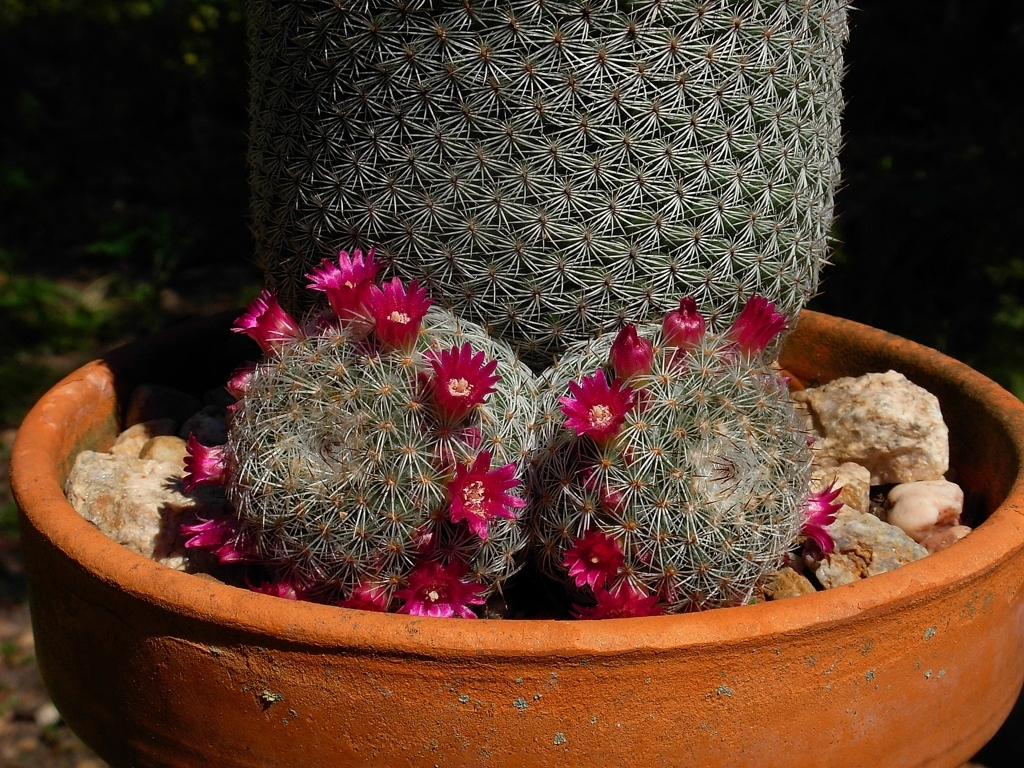Could you describe the types of thorns this cactus has? Certainly, the cactus has an array of closely packed, needle-like spines covering its surface. These spines vary in length and are an adaptation to protect the cactus from herbivores and to provide shade for the surface of the plant. 